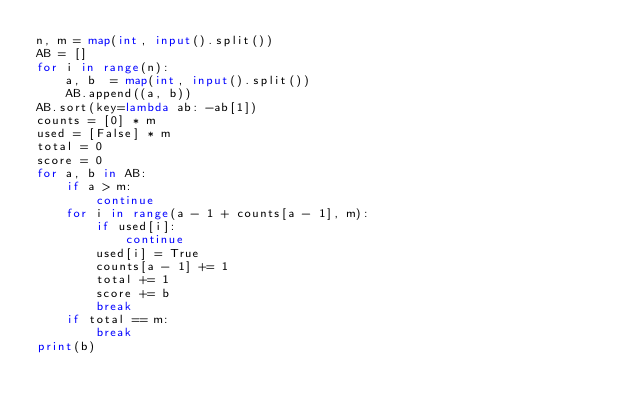<code> <loc_0><loc_0><loc_500><loc_500><_Python_>n, m = map(int, input().split())
AB = []
for i in range(n):
    a, b  = map(int, input().split())
    AB.append((a, b))
AB.sort(key=lambda ab: -ab[1])
counts = [0] * m
used = [False] * m
total = 0
score = 0
for a, b in AB:
    if a > m:
        continue
    for i in range(a - 1 + counts[a - 1], m):
        if used[i]:
            continue
        used[i] = True
        counts[a - 1] += 1
        total += 1
        score += b
        break
    if total == m:
        break
print(b)
</code> 